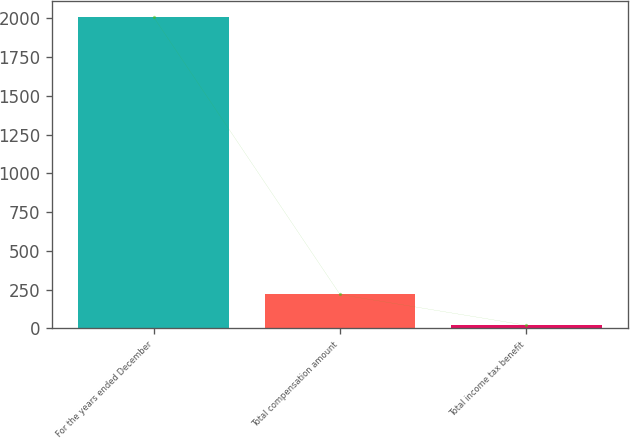Convert chart. <chart><loc_0><loc_0><loc_500><loc_500><bar_chart><fcel>For the years ended December<fcel>Total compensation amount<fcel>Total income tax benefit<nl><fcel>2009<fcel>218.09<fcel>19.1<nl></chart> 